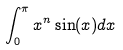<formula> <loc_0><loc_0><loc_500><loc_500>\int _ { 0 } ^ { \pi } x ^ { n } \sin ( x ) d x</formula> 